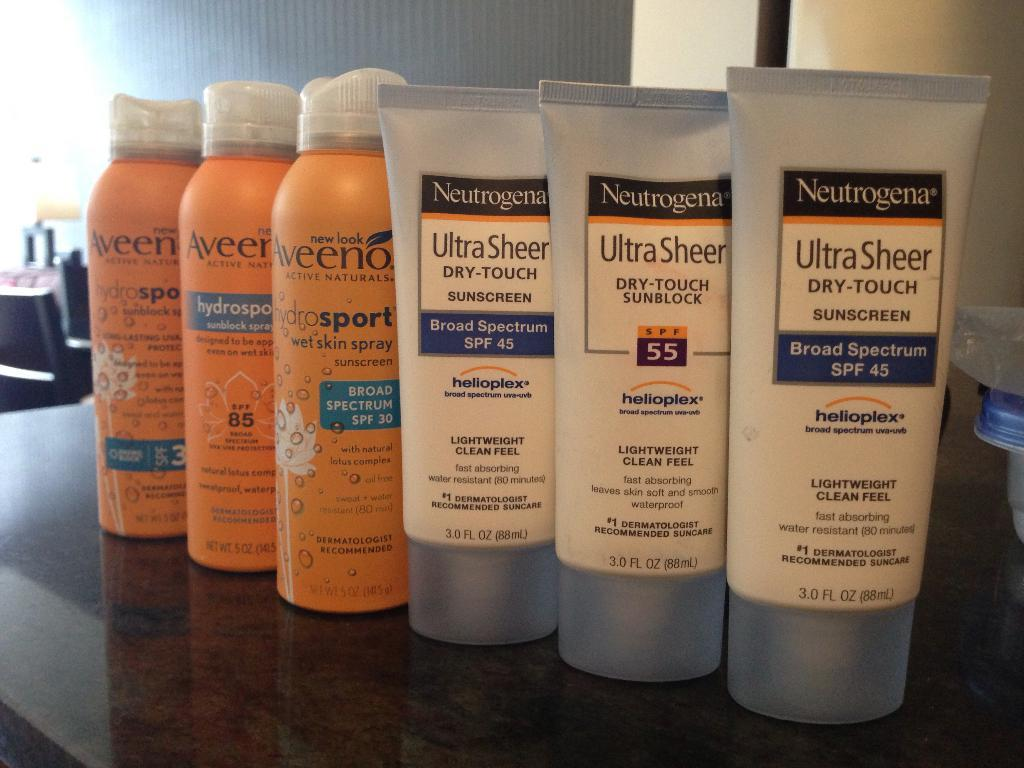<image>
Present a compact description of the photo's key features. the words ultra sheer are on some items 